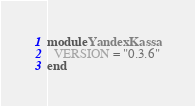Convert code to text. <code><loc_0><loc_0><loc_500><loc_500><_Ruby_>module YandexKassa
  VERSION = "0.3.6"
end
</code> 